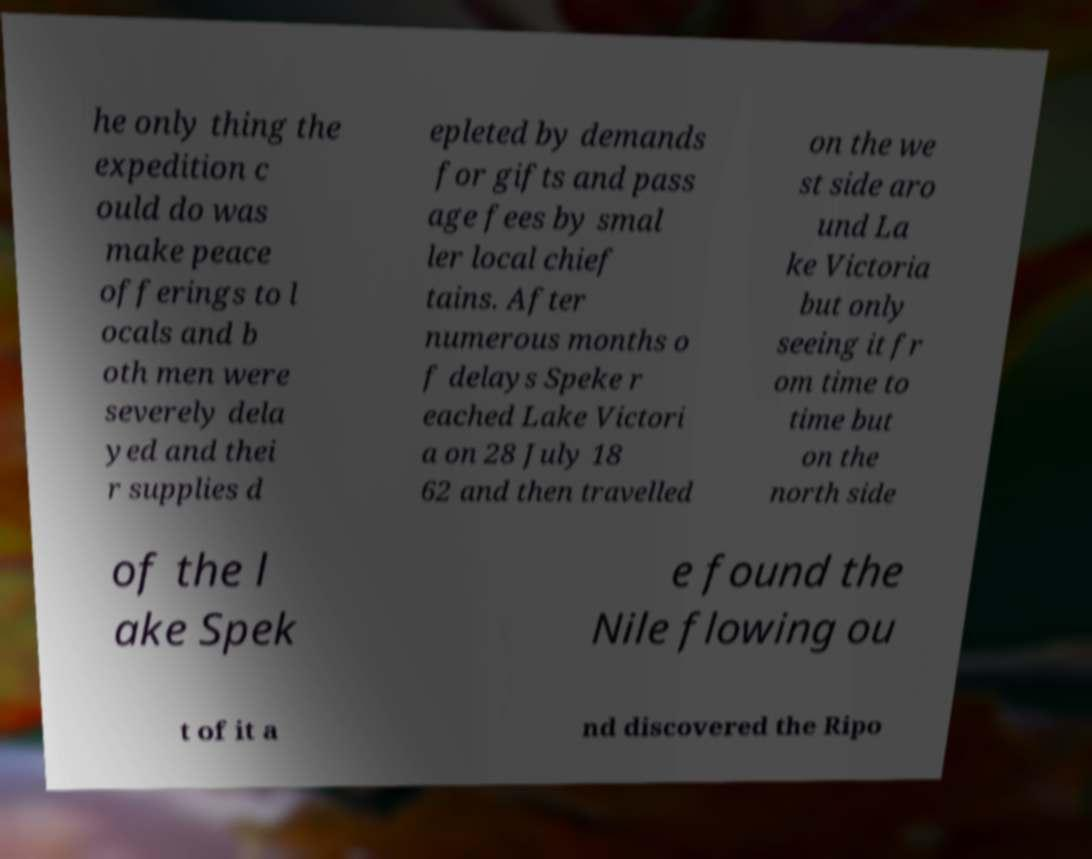Can you read and provide the text displayed in the image?This photo seems to have some interesting text. Can you extract and type it out for me? he only thing the expedition c ould do was make peace offerings to l ocals and b oth men were severely dela yed and thei r supplies d epleted by demands for gifts and pass age fees by smal ler local chief tains. After numerous months o f delays Speke r eached Lake Victori a on 28 July 18 62 and then travelled on the we st side aro und La ke Victoria but only seeing it fr om time to time but on the north side of the l ake Spek e found the Nile flowing ou t of it a nd discovered the Ripo 